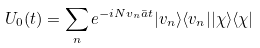Convert formula to latex. <formula><loc_0><loc_0><loc_500><loc_500>U _ { 0 } ( t ) = \sum _ { n } e ^ { - i N v _ { n } \bar { a } t } | v _ { n } \rangle \langle v _ { n } | | \chi \rangle \langle \chi |</formula> 